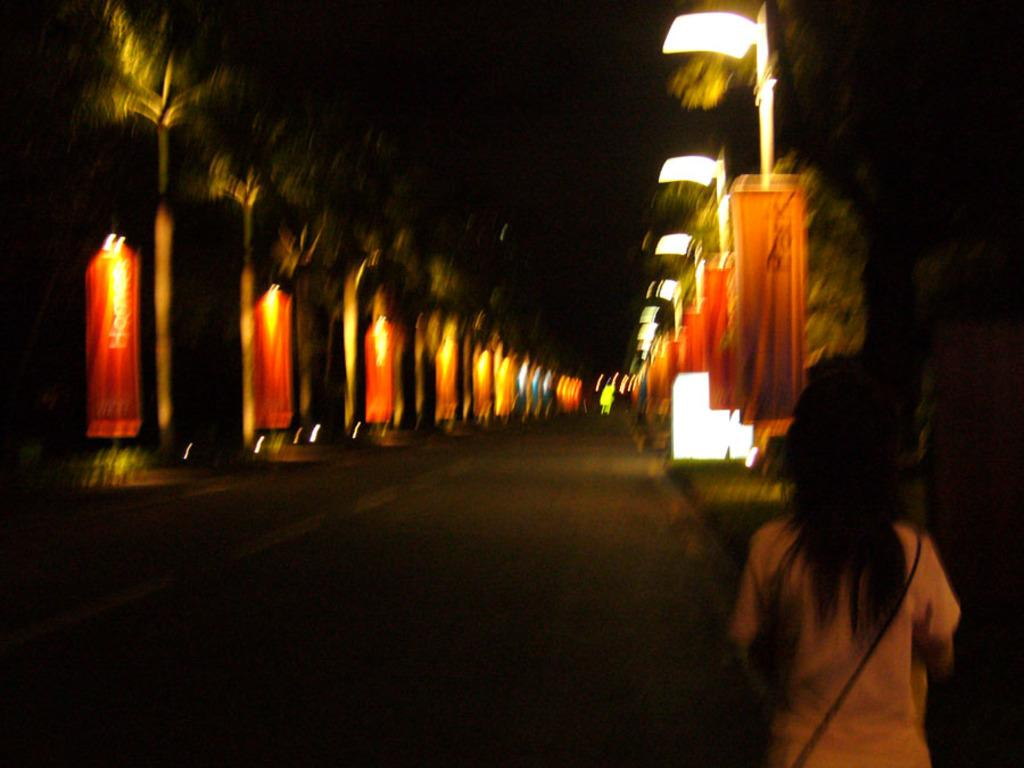What is the position of the person in the image? There is a person standing on the right side of the image. What can be seen in the background of the image? There are poles, lights, trees, and the sky visible in the background of the image. What type of cart is being used by the person in the image? There is no cart present in the image; the person is standing. What is the person using to dig in the image? There is no digging activity or spade present in the image. 